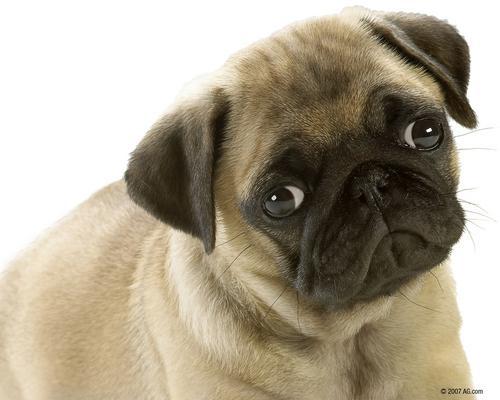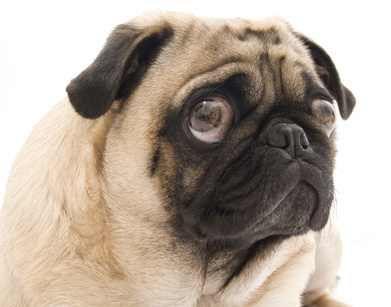The first image is the image on the left, the second image is the image on the right. Analyze the images presented: Is the assertion "Whites of the eyes are very visible on the dog on the left." valid? Answer yes or no. Yes. 